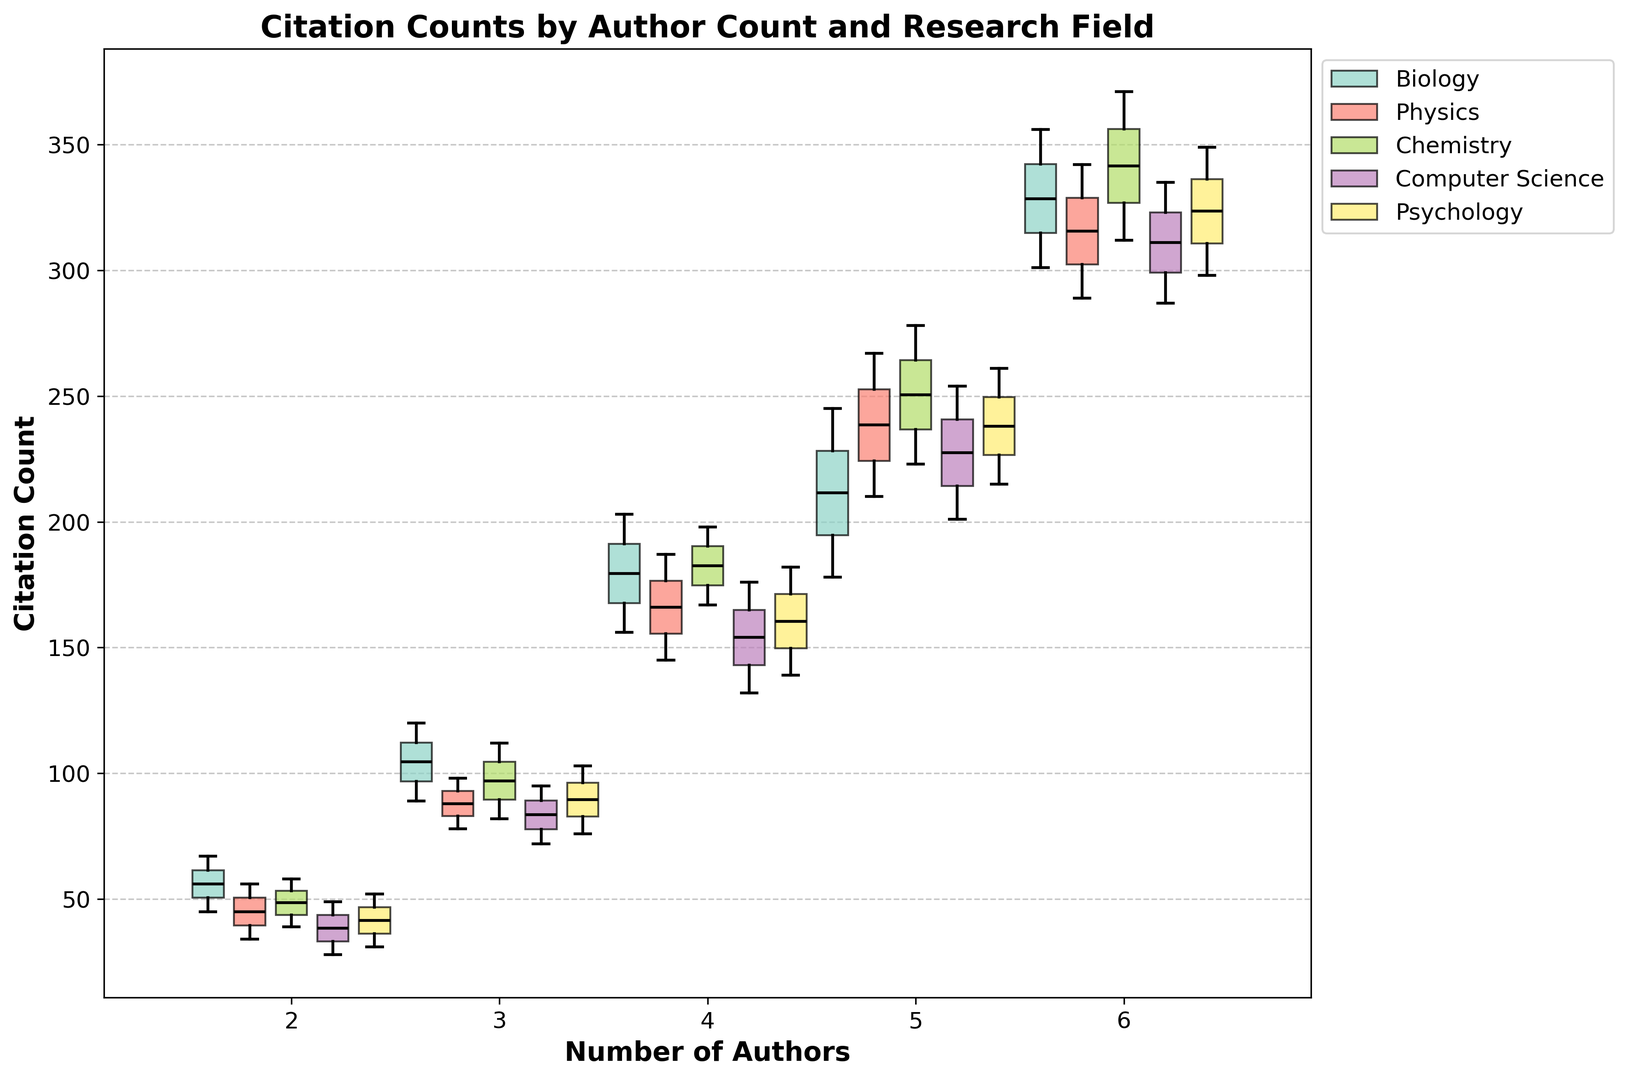What is the median citation count for papers in the field of Chemistry with 4 authors? First, locate the box plot corresponding to Chemistry and then identify the box for 4 authors. The median is represented by the line inside this box.
Answer: 167 Which field has the highest maximum citation count for papers with 6 authors? Find the box plots for papers with 6 authors across all fields and compare the values at the top whisker of each box plot. The highest value represents the field with the highest maximum citation count.
Answer: Chemistry In the field of Physics, how does the median citation count differ between papers with 2 authors and papers with 5 authors? Locate the Physics box plots for 2 authors and 5 authors and identify their medians. Subtract the median for 2 authors from the median for 5 authors to find the difference.
Answer: 176 What is the trend in median citation count as the number of authors increases from 2 to 6 in the field of Biology? Examine the median values for each author count (2, 3, 4, 5, 6) in the Biology box plots and observe the trend.
Answer: Increasing Which research field has the most consistent citation counts as indicated by the smallest interquartile range for papers with 3 authors? For papers with 3 authors, find the interquartile ranges in the box plots of all fields (the range between the top and bottom edges of the box). The smallest range indicates the most consistent citation counts.
Answer: Physics 